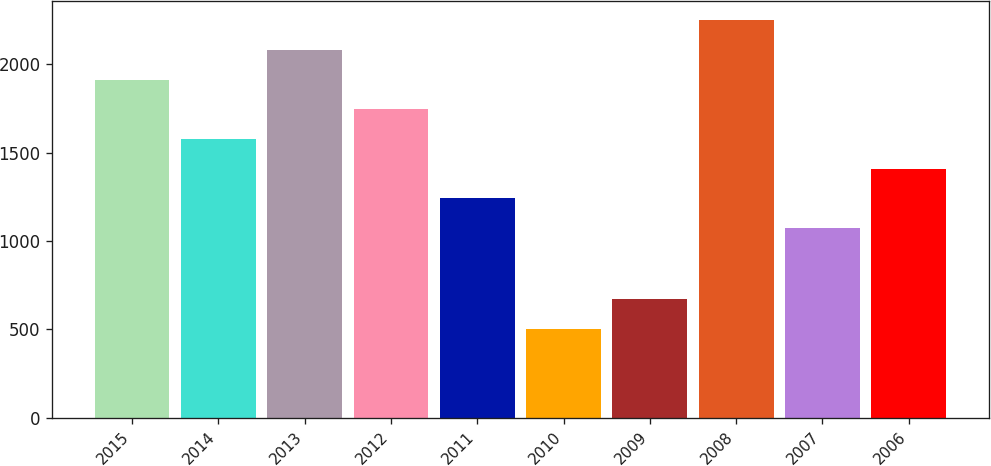<chart> <loc_0><loc_0><loc_500><loc_500><bar_chart><fcel>2015<fcel>2014<fcel>2013<fcel>2012<fcel>2011<fcel>2010<fcel>2009<fcel>2008<fcel>2007<fcel>2006<nl><fcel>1913.5<fcel>1578.1<fcel>2081.2<fcel>1745.8<fcel>1242.7<fcel>503<fcel>670.7<fcel>2248.9<fcel>1075<fcel>1410.4<nl></chart> 